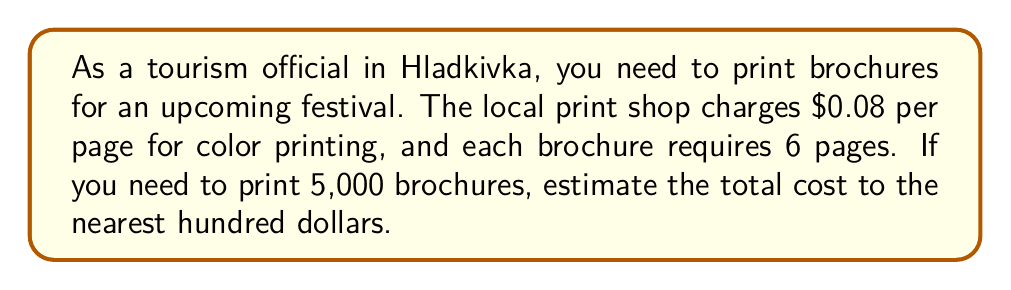Solve this math problem. Let's approach this step-by-step:

1. Calculate the cost per brochure:
   - Each brochure has 6 pages
   - Each page costs $0.08
   - Cost per brochure = $6 \times $0.08 = $0.48

2. Calculate the total cost for 5,000 brochures:
   $$ \text{Total Cost} = 5,000 \times $0.48 = $2,400 $$

3. Round to the nearest hundred dollars:
   $2,400 is already at an exact hundred, so no rounding is necessary.

Therefore, the estimated cost for printing 5,000 brochures is $2,400.
Answer: $2,400 